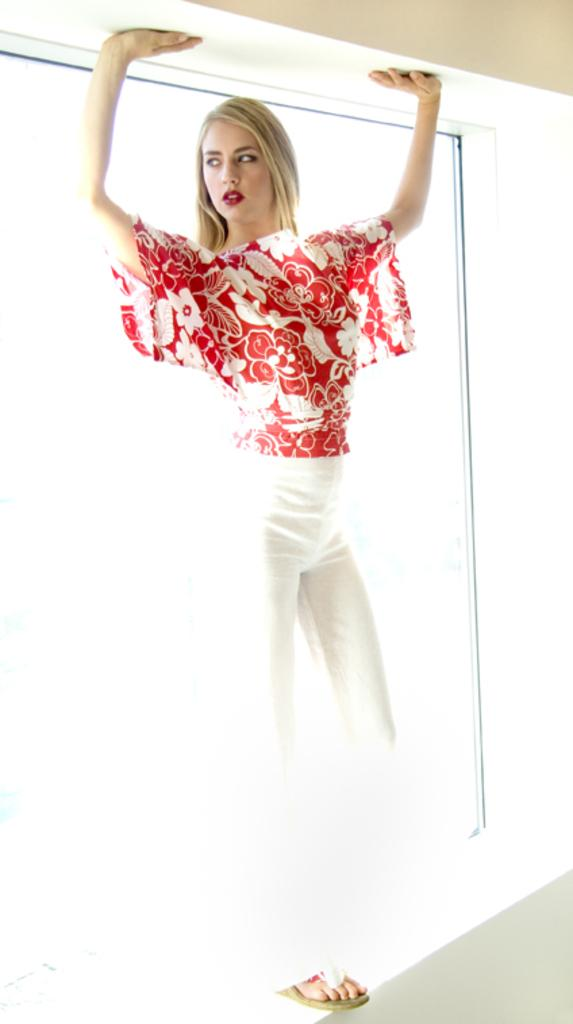What is the main subject of the image? There is a woman in the image. What is the woman wearing? The woman is wearing a red top and white pants. Where is the woman located in the image? The woman is standing on a wall. What can be seen in the background of the image? There is a window in the background of the image. What architectural feature is visible at the top of the image? There is a beam at the top of the image. What color is the division between the red top and white pants? There is no division between the red top and white pants mentioned in the image, as the woman is wearing a red top and white pants as separate pieces of clothing. 